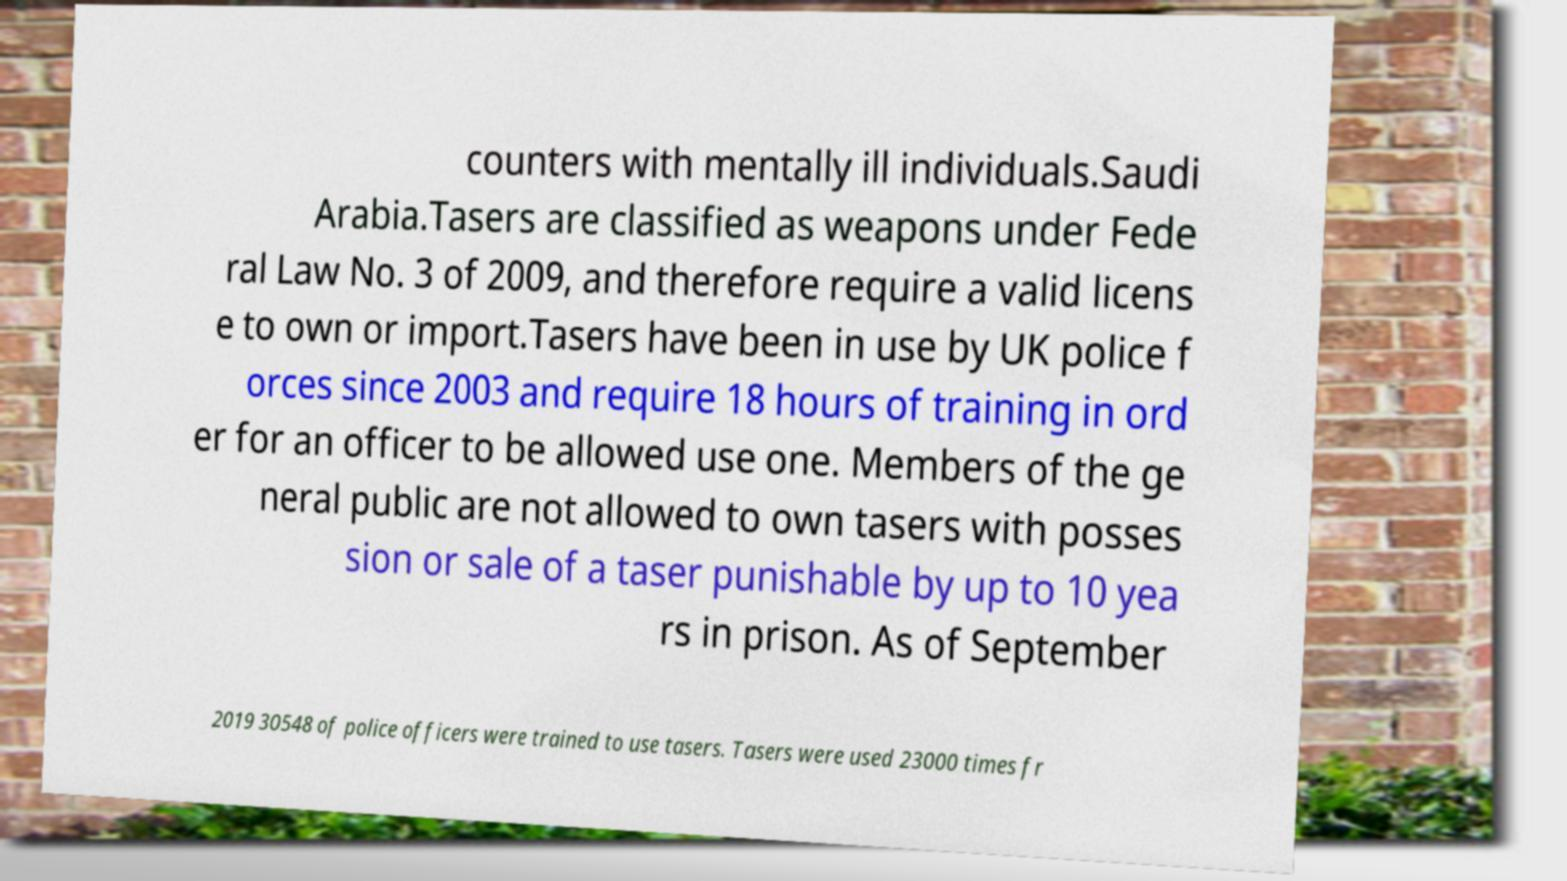There's text embedded in this image that I need extracted. Can you transcribe it verbatim? counters with mentally ill individuals.Saudi Arabia.Tasers are classified as weapons under Fede ral Law No. 3 of 2009, and therefore require a valid licens e to own or import.Tasers have been in use by UK police f orces since 2003 and require 18 hours of training in ord er for an officer to be allowed use one. Members of the ge neral public are not allowed to own tasers with posses sion or sale of a taser punishable by up to 10 yea rs in prison. As of September 2019 30548 of police officers were trained to use tasers. Tasers were used 23000 times fr 